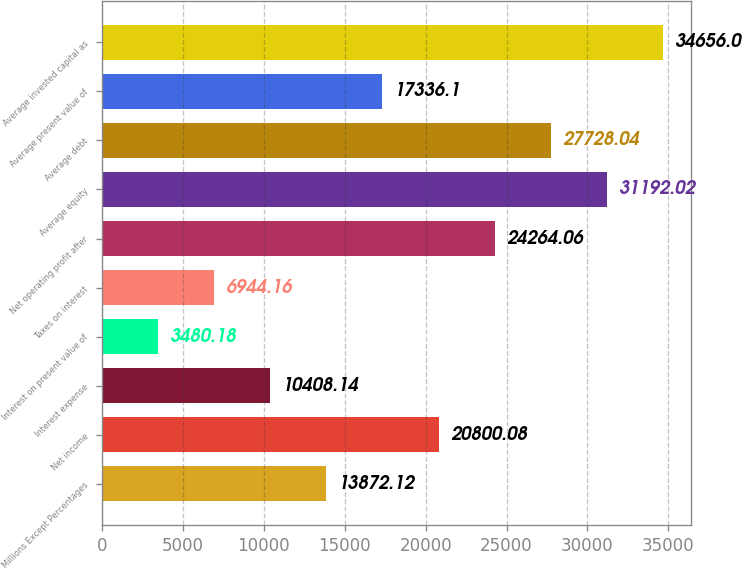Convert chart to OTSL. <chart><loc_0><loc_0><loc_500><loc_500><bar_chart><fcel>Millions Except Percentages<fcel>Net income<fcel>Interest expense<fcel>Interest on present value of<fcel>Taxes on interest<fcel>Net operating profit after<fcel>Average equity<fcel>Average debt<fcel>Average present value of<fcel>Average invested capital as<nl><fcel>13872.1<fcel>20800.1<fcel>10408.1<fcel>3480.18<fcel>6944.16<fcel>24264.1<fcel>31192<fcel>27728<fcel>17336.1<fcel>34656<nl></chart> 